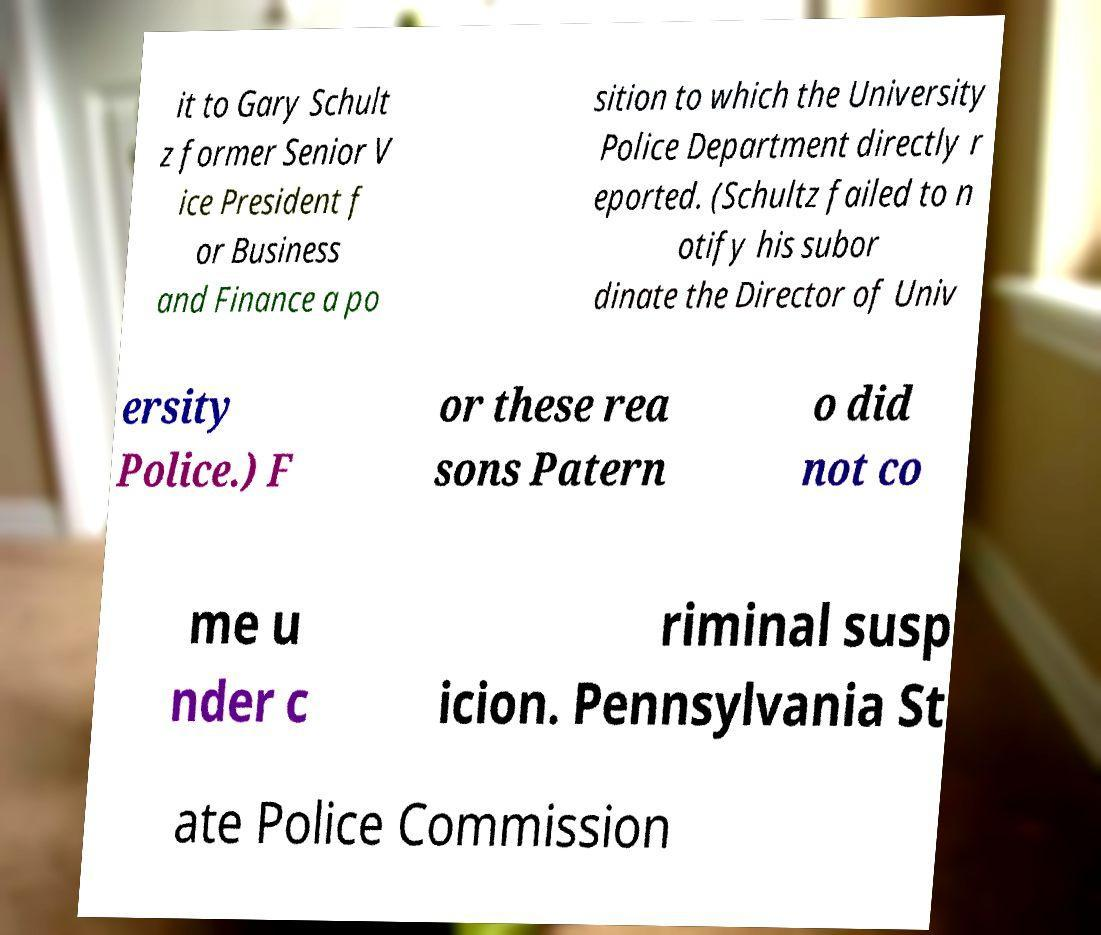Could you assist in decoding the text presented in this image and type it out clearly? it to Gary Schult z former Senior V ice President f or Business and Finance a po sition to which the University Police Department directly r eported. (Schultz failed to n otify his subor dinate the Director of Univ ersity Police.) F or these rea sons Patern o did not co me u nder c riminal susp icion. Pennsylvania St ate Police Commission 